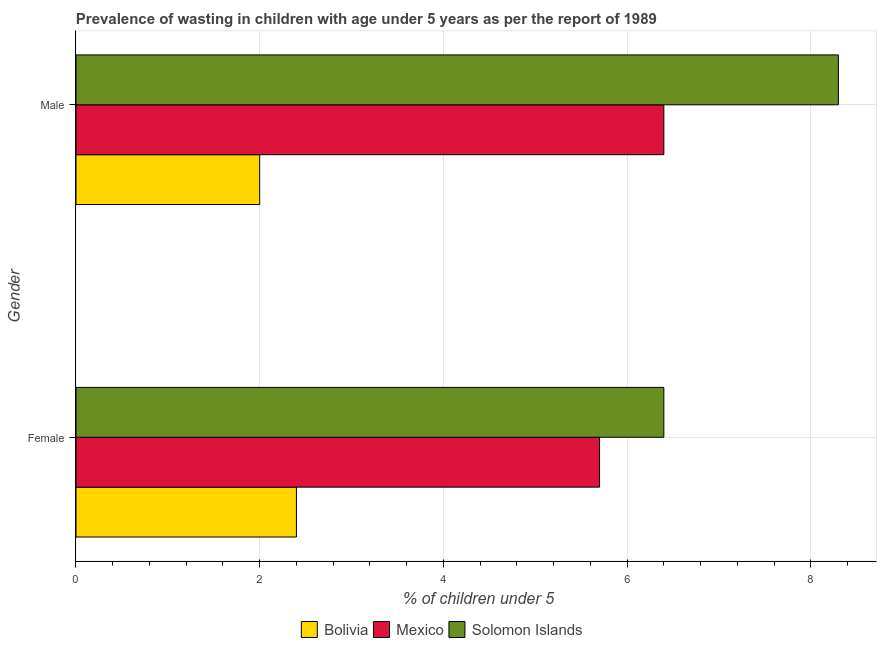How many different coloured bars are there?
Offer a terse response. 3. How many groups of bars are there?
Your answer should be very brief. 2. Are the number of bars on each tick of the Y-axis equal?
Provide a succinct answer. Yes. What is the label of the 1st group of bars from the top?
Provide a succinct answer. Male. What is the percentage of undernourished male children in Mexico?
Ensure brevity in your answer.  6.4. Across all countries, what is the maximum percentage of undernourished male children?
Your answer should be very brief. 8.3. Across all countries, what is the minimum percentage of undernourished female children?
Provide a short and direct response. 2.4. In which country was the percentage of undernourished male children maximum?
Give a very brief answer. Solomon Islands. In which country was the percentage of undernourished male children minimum?
Your answer should be very brief. Bolivia. What is the total percentage of undernourished female children in the graph?
Offer a terse response. 14.5. What is the difference between the percentage of undernourished female children in Solomon Islands and that in Mexico?
Your answer should be very brief. 0.7. What is the difference between the percentage of undernourished male children in Solomon Islands and the percentage of undernourished female children in Mexico?
Give a very brief answer. 2.6. What is the average percentage of undernourished female children per country?
Provide a short and direct response. 4.83. What is the difference between the percentage of undernourished male children and percentage of undernourished female children in Solomon Islands?
Give a very brief answer. 1.9. What is the ratio of the percentage of undernourished male children in Mexico to that in Bolivia?
Your answer should be very brief. 3.2. What does the 3rd bar from the bottom in Female represents?
Keep it short and to the point. Solomon Islands. What is the difference between two consecutive major ticks on the X-axis?
Offer a terse response. 2. Are the values on the major ticks of X-axis written in scientific E-notation?
Your response must be concise. No. Does the graph contain grids?
Ensure brevity in your answer.  Yes. How many legend labels are there?
Make the answer very short. 3. What is the title of the graph?
Provide a short and direct response. Prevalence of wasting in children with age under 5 years as per the report of 1989. What is the label or title of the X-axis?
Offer a very short reply.  % of children under 5. What is the  % of children under 5 of Bolivia in Female?
Provide a succinct answer. 2.4. What is the  % of children under 5 of Mexico in Female?
Provide a succinct answer. 5.7. What is the  % of children under 5 in Solomon Islands in Female?
Ensure brevity in your answer.  6.4. What is the  % of children under 5 of Bolivia in Male?
Provide a short and direct response. 2. What is the  % of children under 5 in Mexico in Male?
Provide a succinct answer. 6.4. What is the  % of children under 5 in Solomon Islands in Male?
Your answer should be very brief. 8.3. Across all Gender, what is the maximum  % of children under 5 in Bolivia?
Keep it short and to the point. 2.4. Across all Gender, what is the maximum  % of children under 5 of Mexico?
Your answer should be very brief. 6.4. Across all Gender, what is the maximum  % of children under 5 of Solomon Islands?
Offer a very short reply. 8.3. Across all Gender, what is the minimum  % of children under 5 in Bolivia?
Your answer should be compact. 2. Across all Gender, what is the minimum  % of children under 5 of Mexico?
Make the answer very short. 5.7. Across all Gender, what is the minimum  % of children under 5 in Solomon Islands?
Your answer should be very brief. 6.4. What is the total  % of children under 5 in Mexico in the graph?
Provide a succinct answer. 12.1. What is the difference between the  % of children under 5 of Mexico in Female and that in Male?
Make the answer very short. -0.7. What is the difference between the  % of children under 5 in Solomon Islands in Female and that in Male?
Make the answer very short. -1.9. What is the difference between the  % of children under 5 of Bolivia in Female and the  % of children under 5 of Mexico in Male?
Your answer should be very brief. -4. What is the difference between the  % of children under 5 of Bolivia in Female and the  % of children under 5 of Solomon Islands in Male?
Ensure brevity in your answer.  -5.9. What is the difference between the  % of children under 5 in Mexico in Female and the  % of children under 5 in Solomon Islands in Male?
Ensure brevity in your answer.  -2.6. What is the average  % of children under 5 of Bolivia per Gender?
Provide a succinct answer. 2.2. What is the average  % of children under 5 in Mexico per Gender?
Offer a terse response. 6.05. What is the average  % of children under 5 in Solomon Islands per Gender?
Offer a terse response. 7.35. What is the difference between the  % of children under 5 in Bolivia and  % of children under 5 in Mexico in Female?
Give a very brief answer. -3.3. What is the ratio of the  % of children under 5 in Mexico in Female to that in Male?
Make the answer very short. 0.89. What is the ratio of the  % of children under 5 of Solomon Islands in Female to that in Male?
Keep it short and to the point. 0.77. What is the difference between the highest and the second highest  % of children under 5 in Solomon Islands?
Provide a succinct answer. 1.9. What is the difference between the highest and the lowest  % of children under 5 in Bolivia?
Your answer should be compact. 0.4. What is the difference between the highest and the lowest  % of children under 5 in Solomon Islands?
Keep it short and to the point. 1.9. 